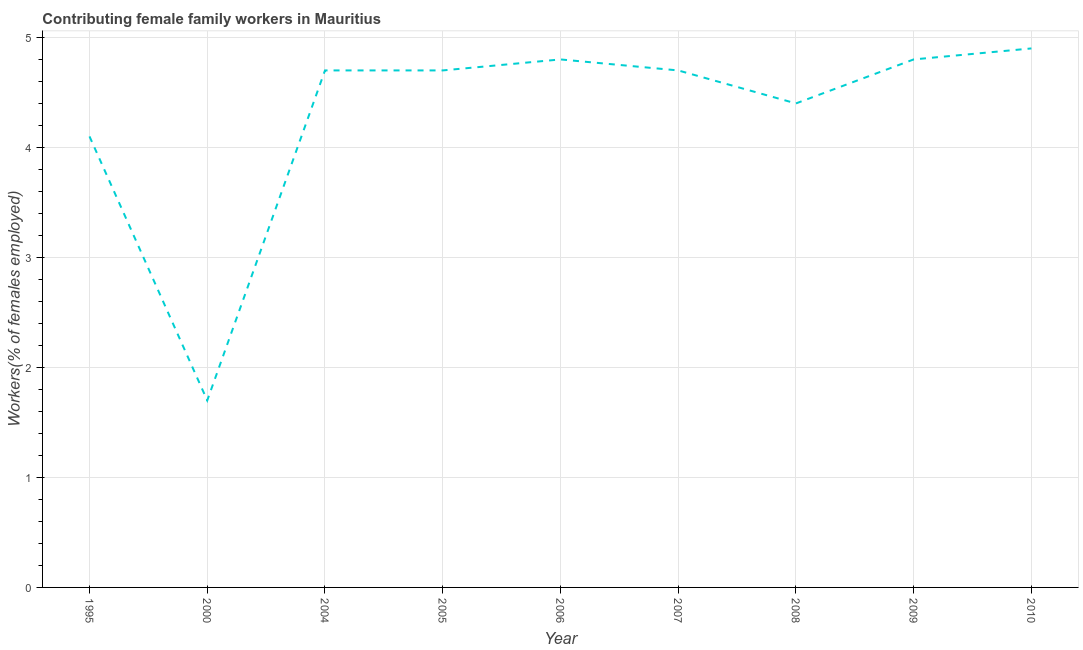What is the contributing female family workers in 2005?
Your answer should be very brief. 4.7. Across all years, what is the maximum contributing female family workers?
Your answer should be compact. 4.9. Across all years, what is the minimum contributing female family workers?
Ensure brevity in your answer.  1.7. In which year was the contributing female family workers maximum?
Make the answer very short. 2010. What is the sum of the contributing female family workers?
Give a very brief answer. 38.8. What is the difference between the contributing female family workers in 2000 and 2005?
Give a very brief answer. -3. What is the average contributing female family workers per year?
Offer a very short reply. 4.31. What is the median contributing female family workers?
Your response must be concise. 4.7. In how many years, is the contributing female family workers greater than 1.4 %?
Offer a very short reply. 9. Do a majority of the years between 1995 and 2000 (inclusive) have contributing female family workers greater than 1 %?
Provide a succinct answer. Yes. What is the ratio of the contributing female family workers in 1995 to that in 2007?
Offer a terse response. 0.87. Is the difference between the contributing female family workers in 2000 and 2006 greater than the difference between any two years?
Offer a very short reply. No. What is the difference between the highest and the second highest contributing female family workers?
Offer a terse response. 0.1. Is the sum of the contributing female family workers in 2005 and 2008 greater than the maximum contributing female family workers across all years?
Provide a short and direct response. Yes. What is the difference between the highest and the lowest contributing female family workers?
Your answer should be compact. 3.2. In how many years, is the contributing female family workers greater than the average contributing female family workers taken over all years?
Offer a terse response. 7. How many lines are there?
Offer a very short reply. 1. How many years are there in the graph?
Offer a very short reply. 9. What is the difference between two consecutive major ticks on the Y-axis?
Your answer should be very brief. 1. Does the graph contain any zero values?
Keep it short and to the point. No. Does the graph contain grids?
Your response must be concise. Yes. What is the title of the graph?
Provide a succinct answer. Contributing female family workers in Mauritius. What is the label or title of the Y-axis?
Your answer should be compact. Workers(% of females employed). What is the Workers(% of females employed) in 1995?
Provide a short and direct response. 4.1. What is the Workers(% of females employed) in 2000?
Ensure brevity in your answer.  1.7. What is the Workers(% of females employed) of 2004?
Give a very brief answer. 4.7. What is the Workers(% of females employed) of 2005?
Give a very brief answer. 4.7. What is the Workers(% of females employed) of 2006?
Your response must be concise. 4.8. What is the Workers(% of females employed) in 2007?
Keep it short and to the point. 4.7. What is the Workers(% of females employed) of 2008?
Your response must be concise. 4.4. What is the Workers(% of females employed) of 2009?
Keep it short and to the point. 4.8. What is the Workers(% of females employed) in 2010?
Your response must be concise. 4.9. What is the difference between the Workers(% of females employed) in 1995 and 2000?
Offer a very short reply. 2.4. What is the difference between the Workers(% of females employed) in 1995 and 2005?
Provide a short and direct response. -0.6. What is the difference between the Workers(% of females employed) in 1995 and 2008?
Your response must be concise. -0.3. What is the difference between the Workers(% of females employed) in 1995 and 2010?
Offer a very short reply. -0.8. What is the difference between the Workers(% of females employed) in 2000 and 2009?
Your answer should be very brief. -3.1. What is the difference between the Workers(% of females employed) in 2004 and 2006?
Provide a succinct answer. -0.1. What is the difference between the Workers(% of females employed) in 2004 and 2007?
Provide a short and direct response. 0. What is the difference between the Workers(% of females employed) in 2004 and 2009?
Provide a succinct answer. -0.1. What is the difference between the Workers(% of females employed) in 2004 and 2010?
Give a very brief answer. -0.2. What is the difference between the Workers(% of females employed) in 2005 and 2007?
Provide a short and direct response. 0. What is the difference between the Workers(% of females employed) in 2005 and 2008?
Make the answer very short. 0.3. What is the difference between the Workers(% of females employed) in 2005 and 2010?
Your response must be concise. -0.2. What is the difference between the Workers(% of females employed) in 2006 and 2007?
Give a very brief answer. 0.1. What is the difference between the Workers(% of females employed) in 2006 and 2009?
Make the answer very short. 0. What is the difference between the Workers(% of females employed) in 2007 and 2009?
Your answer should be very brief. -0.1. What is the difference between the Workers(% of females employed) in 2008 and 2010?
Make the answer very short. -0.5. What is the ratio of the Workers(% of females employed) in 1995 to that in 2000?
Keep it short and to the point. 2.41. What is the ratio of the Workers(% of females employed) in 1995 to that in 2004?
Make the answer very short. 0.87. What is the ratio of the Workers(% of females employed) in 1995 to that in 2005?
Keep it short and to the point. 0.87. What is the ratio of the Workers(% of females employed) in 1995 to that in 2006?
Give a very brief answer. 0.85. What is the ratio of the Workers(% of females employed) in 1995 to that in 2007?
Make the answer very short. 0.87. What is the ratio of the Workers(% of females employed) in 1995 to that in 2008?
Give a very brief answer. 0.93. What is the ratio of the Workers(% of females employed) in 1995 to that in 2009?
Your response must be concise. 0.85. What is the ratio of the Workers(% of females employed) in 1995 to that in 2010?
Keep it short and to the point. 0.84. What is the ratio of the Workers(% of females employed) in 2000 to that in 2004?
Keep it short and to the point. 0.36. What is the ratio of the Workers(% of females employed) in 2000 to that in 2005?
Provide a succinct answer. 0.36. What is the ratio of the Workers(% of females employed) in 2000 to that in 2006?
Provide a succinct answer. 0.35. What is the ratio of the Workers(% of females employed) in 2000 to that in 2007?
Give a very brief answer. 0.36. What is the ratio of the Workers(% of females employed) in 2000 to that in 2008?
Keep it short and to the point. 0.39. What is the ratio of the Workers(% of females employed) in 2000 to that in 2009?
Offer a very short reply. 0.35. What is the ratio of the Workers(% of females employed) in 2000 to that in 2010?
Make the answer very short. 0.35. What is the ratio of the Workers(% of females employed) in 2004 to that in 2008?
Make the answer very short. 1.07. What is the ratio of the Workers(% of females employed) in 2005 to that in 2006?
Ensure brevity in your answer.  0.98. What is the ratio of the Workers(% of females employed) in 2005 to that in 2008?
Keep it short and to the point. 1.07. What is the ratio of the Workers(% of females employed) in 2005 to that in 2009?
Your answer should be compact. 0.98. What is the ratio of the Workers(% of females employed) in 2005 to that in 2010?
Provide a succinct answer. 0.96. What is the ratio of the Workers(% of females employed) in 2006 to that in 2008?
Offer a terse response. 1.09. What is the ratio of the Workers(% of females employed) in 2006 to that in 2009?
Keep it short and to the point. 1. What is the ratio of the Workers(% of females employed) in 2006 to that in 2010?
Keep it short and to the point. 0.98. What is the ratio of the Workers(% of females employed) in 2007 to that in 2008?
Provide a short and direct response. 1.07. What is the ratio of the Workers(% of females employed) in 2008 to that in 2009?
Give a very brief answer. 0.92. What is the ratio of the Workers(% of females employed) in 2008 to that in 2010?
Your answer should be compact. 0.9. 